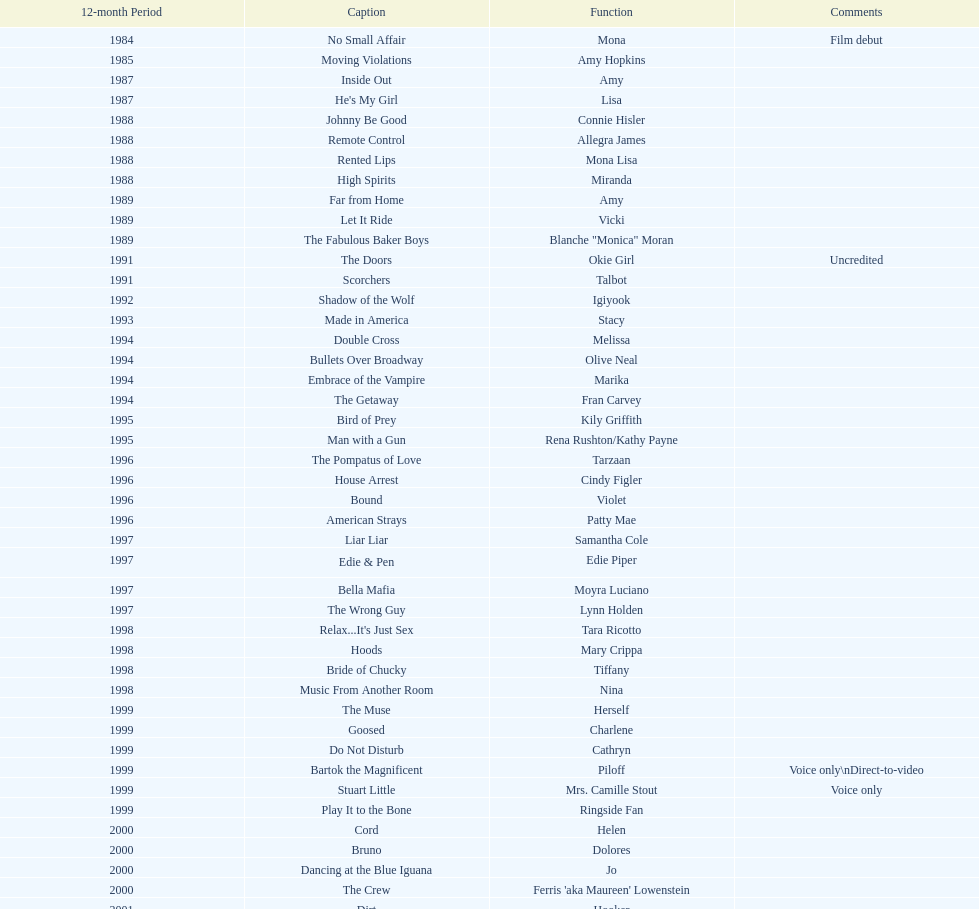Which year had the most credits? 2004. 